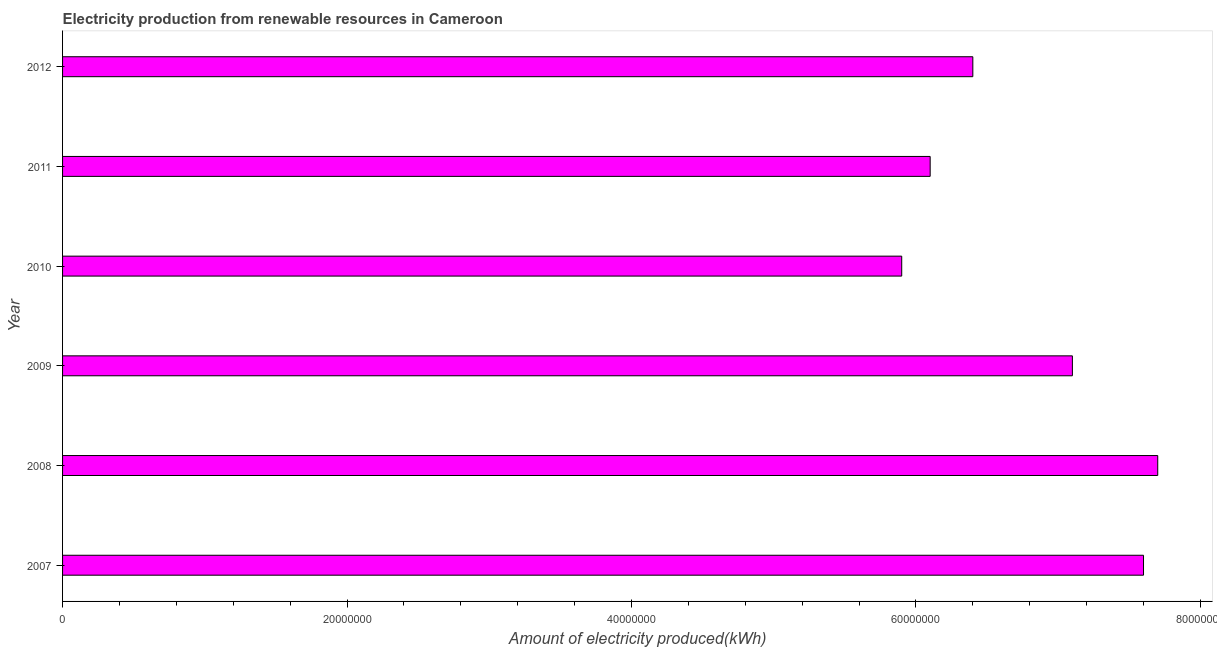Does the graph contain grids?
Give a very brief answer. No. What is the title of the graph?
Your answer should be very brief. Electricity production from renewable resources in Cameroon. What is the label or title of the X-axis?
Offer a very short reply. Amount of electricity produced(kWh). What is the label or title of the Y-axis?
Your answer should be very brief. Year. What is the amount of electricity produced in 2008?
Your answer should be very brief. 7.70e+07. Across all years, what is the maximum amount of electricity produced?
Your answer should be very brief. 7.70e+07. Across all years, what is the minimum amount of electricity produced?
Provide a succinct answer. 5.90e+07. In which year was the amount of electricity produced maximum?
Your answer should be compact. 2008. What is the sum of the amount of electricity produced?
Keep it short and to the point. 4.08e+08. What is the average amount of electricity produced per year?
Provide a succinct answer. 6.80e+07. What is the median amount of electricity produced?
Give a very brief answer. 6.75e+07. Is the amount of electricity produced in 2008 less than that in 2010?
Offer a very short reply. No. What is the difference between the highest and the second highest amount of electricity produced?
Offer a very short reply. 1.00e+06. Is the sum of the amount of electricity produced in 2009 and 2012 greater than the maximum amount of electricity produced across all years?
Provide a short and direct response. Yes. What is the difference between the highest and the lowest amount of electricity produced?
Your response must be concise. 1.80e+07. In how many years, is the amount of electricity produced greater than the average amount of electricity produced taken over all years?
Your answer should be compact. 3. Are all the bars in the graph horizontal?
Give a very brief answer. Yes. How many years are there in the graph?
Provide a succinct answer. 6. What is the difference between two consecutive major ticks on the X-axis?
Your answer should be compact. 2.00e+07. What is the Amount of electricity produced(kWh) in 2007?
Offer a terse response. 7.60e+07. What is the Amount of electricity produced(kWh) of 2008?
Offer a very short reply. 7.70e+07. What is the Amount of electricity produced(kWh) in 2009?
Your answer should be very brief. 7.10e+07. What is the Amount of electricity produced(kWh) of 2010?
Your answer should be compact. 5.90e+07. What is the Amount of electricity produced(kWh) in 2011?
Offer a terse response. 6.10e+07. What is the Amount of electricity produced(kWh) in 2012?
Make the answer very short. 6.40e+07. What is the difference between the Amount of electricity produced(kWh) in 2007 and 2008?
Provide a short and direct response. -1.00e+06. What is the difference between the Amount of electricity produced(kWh) in 2007 and 2010?
Make the answer very short. 1.70e+07. What is the difference between the Amount of electricity produced(kWh) in 2007 and 2011?
Your answer should be compact. 1.50e+07. What is the difference between the Amount of electricity produced(kWh) in 2008 and 2010?
Provide a succinct answer. 1.80e+07. What is the difference between the Amount of electricity produced(kWh) in 2008 and 2011?
Give a very brief answer. 1.60e+07. What is the difference between the Amount of electricity produced(kWh) in 2008 and 2012?
Provide a succinct answer. 1.30e+07. What is the difference between the Amount of electricity produced(kWh) in 2009 and 2010?
Provide a succinct answer. 1.20e+07. What is the difference between the Amount of electricity produced(kWh) in 2009 and 2012?
Provide a succinct answer. 7.00e+06. What is the difference between the Amount of electricity produced(kWh) in 2010 and 2012?
Give a very brief answer. -5.00e+06. What is the ratio of the Amount of electricity produced(kWh) in 2007 to that in 2009?
Your response must be concise. 1.07. What is the ratio of the Amount of electricity produced(kWh) in 2007 to that in 2010?
Your answer should be very brief. 1.29. What is the ratio of the Amount of electricity produced(kWh) in 2007 to that in 2011?
Your response must be concise. 1.25. What is the ratio of the Amount of electricity produced(kWh) in 2007 to that in 2012?
Keep it short and to the point. 1.19. What is the ratio of the Amount of electricity produced(kWh) in 2008 to that in 2009?
Ensure brevity in your answer.  1.08. What is the ratio of the Amount of electricity produced(kWh) in 2008 to that in 2010?
Your response must be concise. 1.3. What is the ratio of the Amount of electricity produced(kWh) in 2008 to that in 2011?
Provide a short and direct response. 1.26. What is the ratio of the Amount of electricity produced(kWh) in 2008 to that in 2012?
Provide a succinct answer. 1.2. What is the ratio of the Amount of electricity produced(kWh) in 2009 to that in 2010?
Provide a succinct answer. 1.2. What is the ratio of the Amount of electricity produced(kWh) in 2009 to that in 2011?
Offer a very short reply. 1.16. What is the ratio of the Amount of electricity produced(kWh) in 2009 to that in 2012?
Offer a terse response. 1.11. What is the ratio of the Amount of electricity produced(kWh) in 2010 to that in 2011?
Make the answer very short. 0.97. What is the ratio of the Amount of electricity produced(kWh) in 2010 to that in 2012?
Give a very brief answer. 0.92. What is the ratio of the Amount of electricity produced(kWh) in 2011 to that in 2012?
Your answer should be compact. 0.95. 